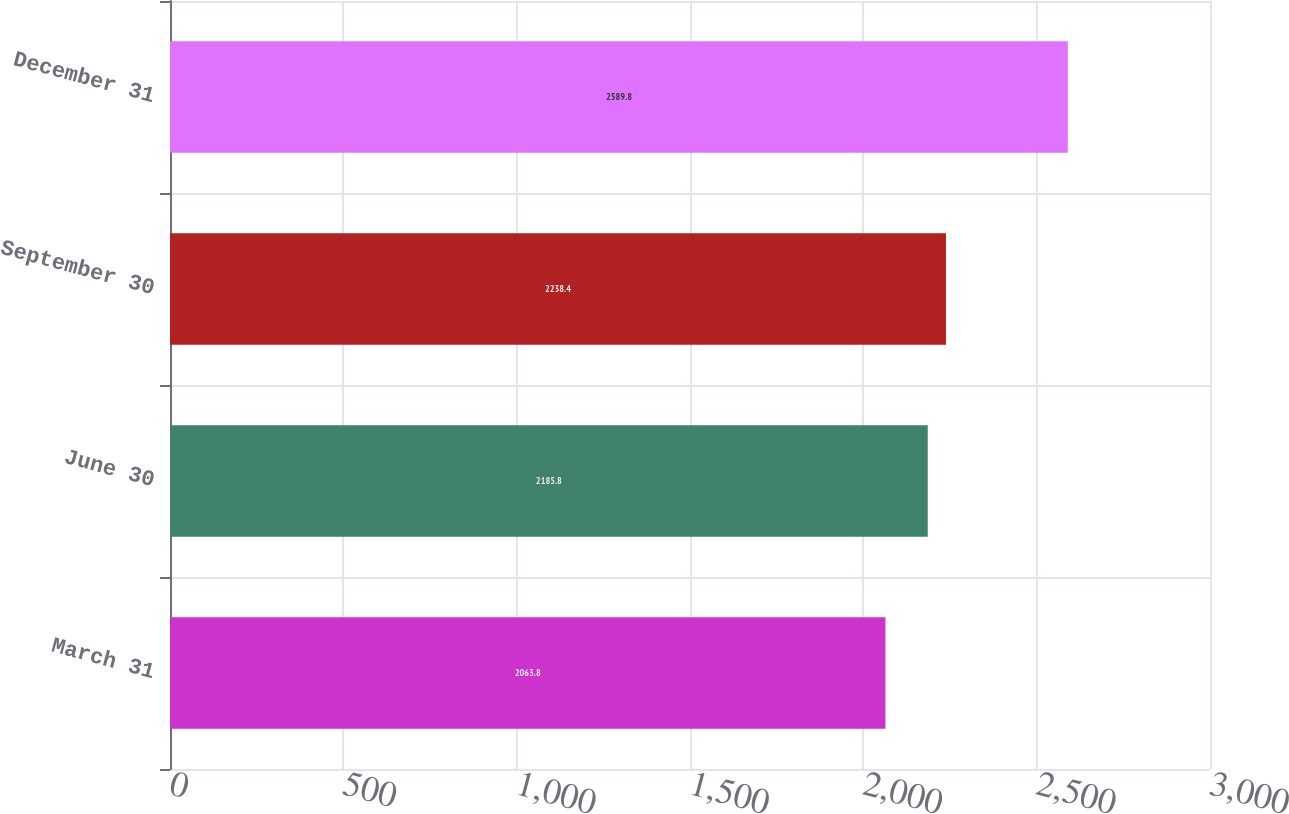Convert chart to OTSL. <chart><loc_0><loc_0><loc_500><loc_500><bar_chart><fcel>March 31<fcel>June 30<fcel>September 30<fcel>December 31<nl><fcel>2063.8<fcel>2185.8<fcel>2238.4<fcel>2589.8<nl></chart> 